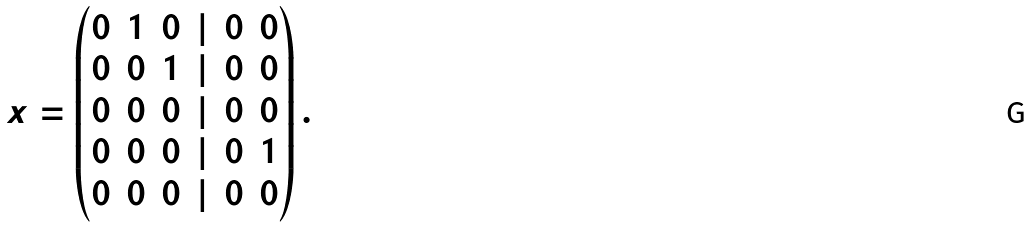Convert formula to latex. <formula><loc_0><loc_0><loc_500><loc_500>x = \left ( \begin{matrix} 0 & 1 & 0 & | & 0 & 0 \\ 0 & 0 & 1 & | & 0 & 0 \\ 0 & 0 & 0 & | & 0 & 0 \\ 0 & 0 & 0 & | & 0 & 1 \\ 0 & 0 & 0 & | & 0 & 0 \\ \end{matrix} \right ) .</formula> 